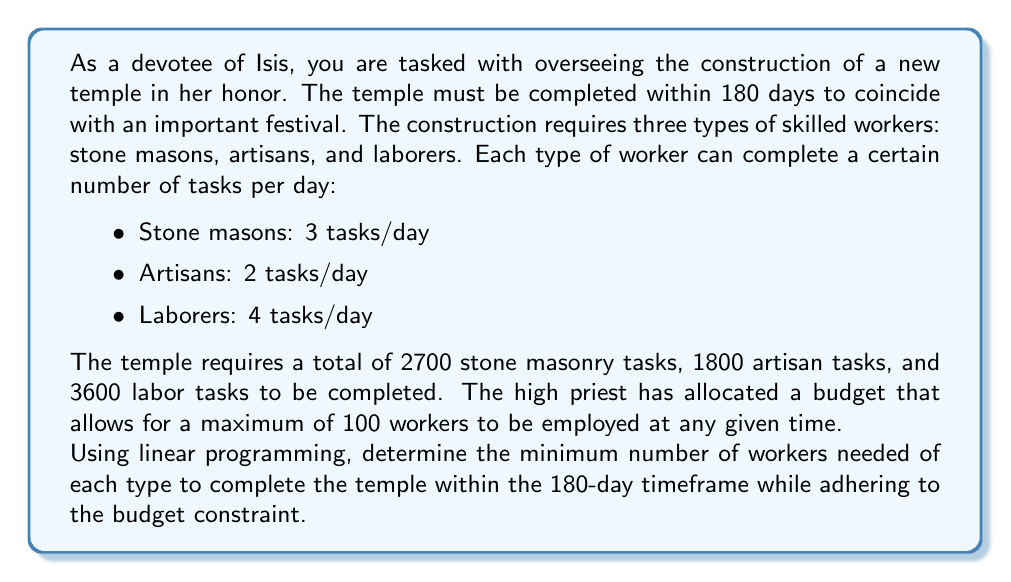Solve this math problem. To solve this problem using linear programming, we need to set up our variables, constraints, and objective function.

Let:
$x$ = number of stone masons
$y$ = number of artisans
$z$ = number of laborers

Objective function (to minimize):
$$\text{minimize } f(x,y,z) = x + y + z$$

Constraints:
1. Time constraint for stone masons: $3x \cdot 180 \geq 2700$
2. Time constraint for artisans: $2y \cdot 180 \geq 1800$
3. Time constraint for laborers: $4z \cdot 180 \geq 3600$
4. Budget constraint: $x + y + z \leq 100$
5. Non-negativity constraints: $x, y, z \geq 0$

Simplifying the time constraints:
1. $540x \geq 2700$ or $x \geq 5$
2. $360y \geq 1800$ or $y \geq 5$
3. $720z \geq 3600$ or $z \geq 5$

Now we have a linear programming problem:

Minimize $x + y + z$
Subject to:
$x \geq 5$
$y \geq 5$
$z \geq 5$
$x + y + z \leq 100$
$x, y, z \geq 0$ and integers

The solution to this problem is the minimum integer values that satisfy all constraints:

$x = 5$
$y = 5$
$z = 5$

We can verify that this solution satisfies all constraints:
1. $5 \geq 5$ (stone masons)
2. $5 \geq 5$ (artisans)
3. $5 \geq 5$ (laborers)
4. $5 + 5 + 5 = 15 \leq 100$ (budget constraint)

Therefore, the minimum number of workers needed is 5 of each type, for a total of 15 workers.
Answer: The minimum number of workers needed to complete the temple within 180 days is 15, consisting of 5 stone masons, 5 artisans, and 5 laborers. 